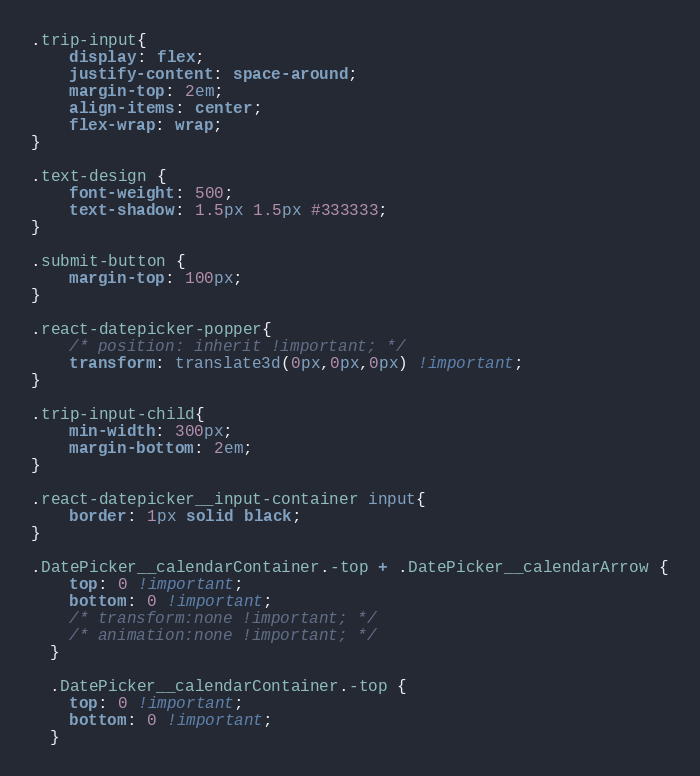<code> <loc_0><loc_0><loc_500><loc_500><_CSS_>.trip-input{
    display: flex;
    justify-content: space-around;
    margin-top: 2em;
    align-items: center;
    flex-wrap: wrap;
}

.text-design {
    font-weight: 500;
    text-shadow: 1.5px 1.5px #333333;
}

.submit-button {
    margin-top: 100px;
}

.react-datepicker-popper{
    /* position: inherit !important; */
    transform: translate3d(0px,0px,0px) !important;
}

.trip-input-child{
    min-width: 300px;
    margin-bottom: 2em;
}

.react-datepicker__input-container input{
    border: 1px solid black;
}

.DatePicker__calendarContainer.-top + .DatePicker__calendarArrow {
    top: 0 !important;
    bottom: 0 !important;
    /* transform:none !important; */
    /* animation:none !important; */
  }

  .DatePicker__calendarContainer.-top {
    top: 0 !important;
    bottom: 0 !important;
  }</code> 